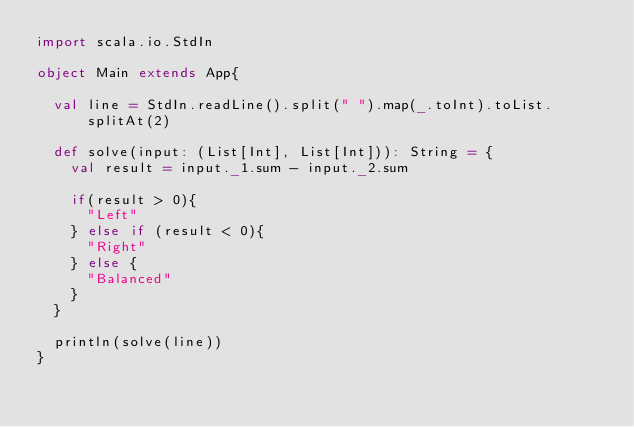<code> <loc_0><loc_0><loc_500><loc_500><_Scala_>import scala.io.StdIn

object Main extends App{

  val line = StdIn.readLine().split(" ").map(_.toInt).toList.splitAt(2)

  def solve(input: (List[Int], List[Int])): String = {
    val result = input._1.sum - input._2.sum

    if(result > 0){
      "Left"
    } else if (result < 0){
      "Right"
    } else {
      "Balanced"
    }
  }

  println(solve(line))
}

</code> 